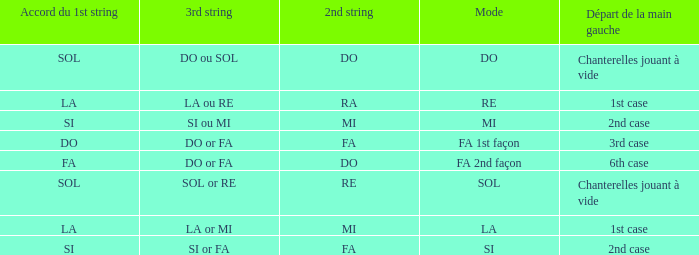What is the Depart de la main gauche of the do Mode? Chanterelles jouant à vide. Would you mind parsing the complete table? {'header': ['Accord du 1st string', '3rd string', '2nd string', 'Mode', 'Départ de la main gauche'], 'rows': [['SOL', 'DO ou SOL', 'DO', 'DO', 'Chanterelles jouant à vide'], ['LA', 'LA ou RE', 'RA', 'RE', '1st case'], ['SI', 'SI ou MI', 'MI', 'MI', '2nd case'], ['DO', 'DO or FA', 'FA', 'FA 1st façon', '3rd case'], ['FA', 'DO or FA', 'DO', 'FA 2nd façon', '6th case'], ['SOL', 'SOL or RE', 'RE', 'SOL', 'Chanterelles jouant à vide'], ['LA', 'LA or MI', 'MI', 'LA', '1st case'], ['SI', 'SI or FA', 'FA', 'SI', '2nd case']]} 